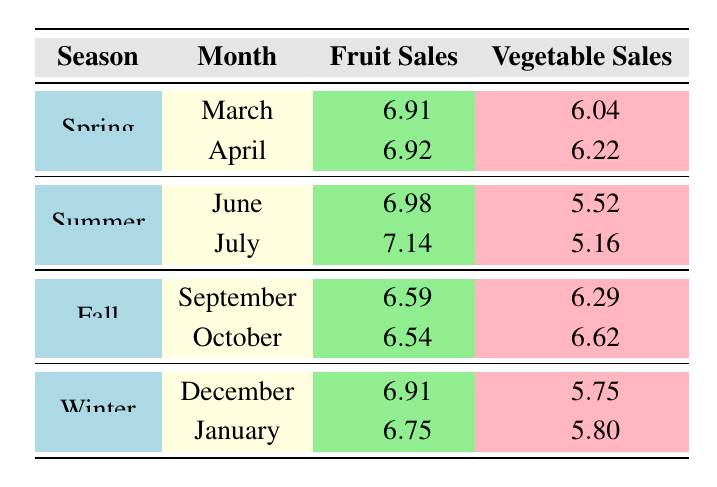What is the total fruit sales for April in Spring? From the table, we see that in April during Spring, the total fruit sales are 6.92 (in logarithmic value). Converting that back from logarithmic to the actual sales volume, we compute 10^6.92, which is approximately 831900.
Answer: 831900 What is the highest vegetable sales recorded in Summer? In the Summer season, we see the vegetable sales for June is 5.52 and for July is 5.16. The highest value is from June.
Answer: 5.52 Is the total sales volume higher in Fall compared to Summer? From the table, we assess the average total sales volume for Fall was (2700 + 3100) / 2 = 2900 and for Summer was (2650 + 2930) / 2 = 2790. Since 2900 > 2790, the total sales volume in Fall is higher than in Summer.
Answer: Yes What is the average fruit sales across all seasons? We sum the fruit sales for each month across all seasons, which is (6.91 + 6.92 + 6.98 + 7.14 + 6.59 + 6.54 + 6.91 + 6.75) = 55.72, and divide by the number of months (8). Therefore, the average fruit sales are 55.72 / 8 ≈ 6.96.
Answer: 6.96 Which month had the lowest sales volume overall? The total sales volumes are 2850 (March), 3050 (April), 2650 (June), 2930 (July), 2700 (September), 3100 (October), 2850 (December), and 3100 (January). The minimum value, 2650 for June, indicates that it had the lowest overall sales volume.
Answer: June 